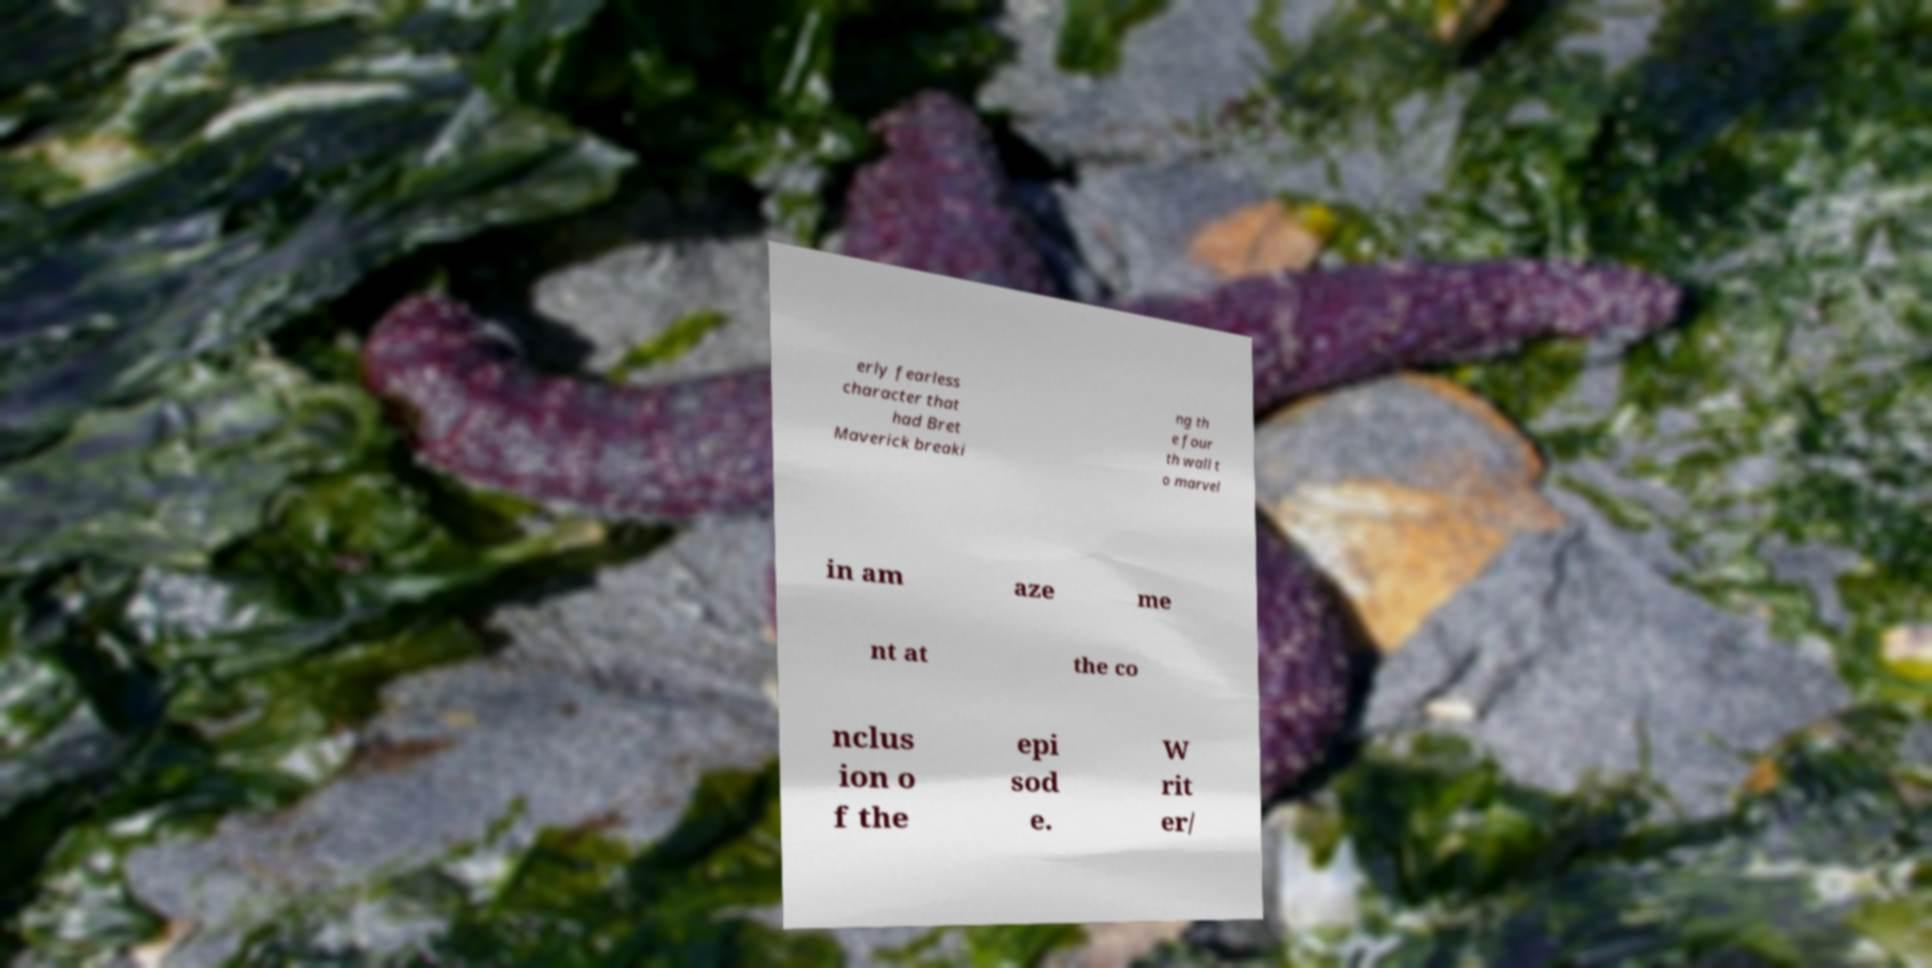Please identify and transcribe the text found in this image. erly fearless character that had Bret Maverick breaki ng th e four th wall t o marvel in am aze me nt at the co nclus ion o f the epi sod e. W rit er/ 